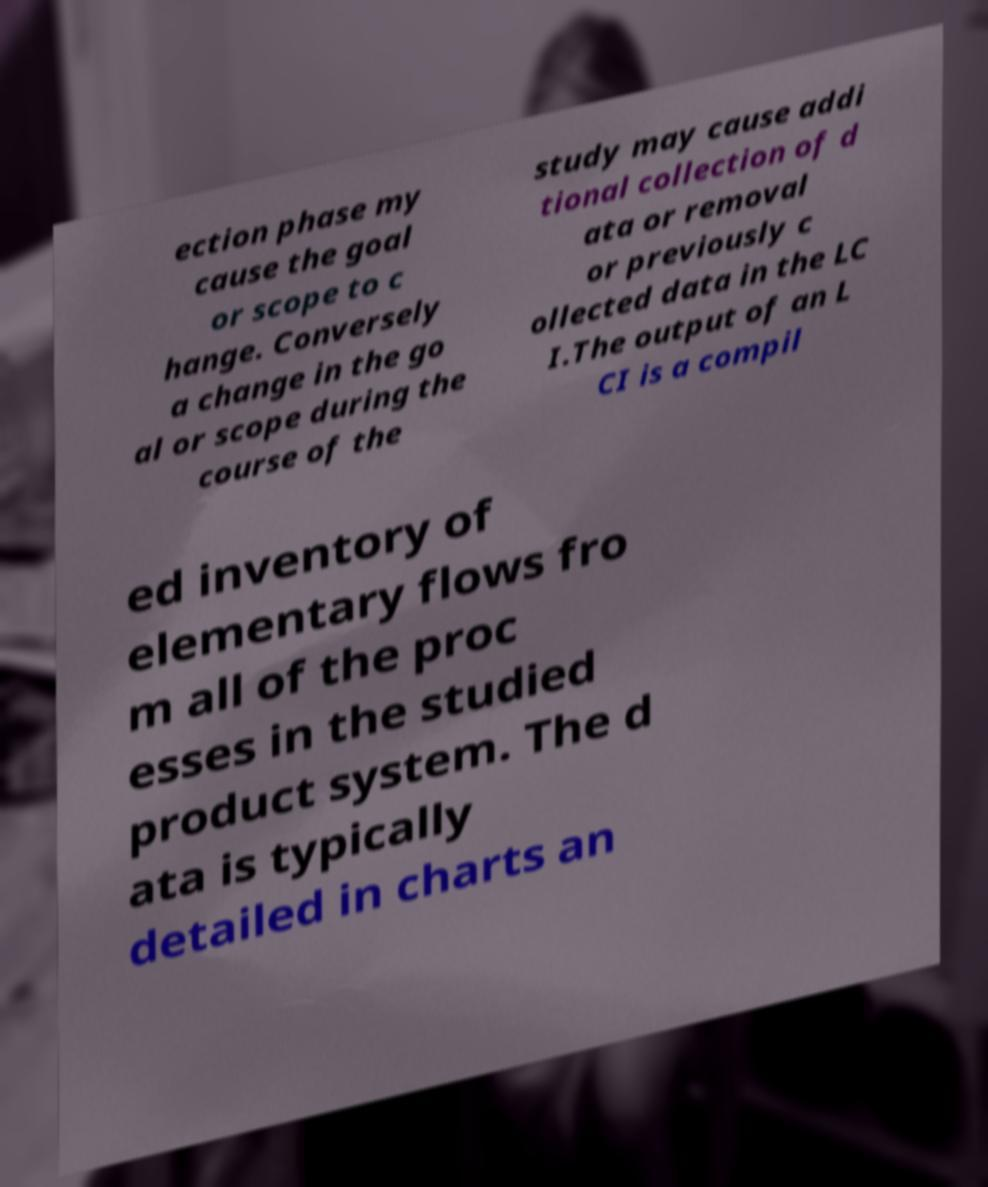What messages or text are displayed in this image? I need them in a readable, typed format. ection phase my cause the goal or scope to c hange. Conversely a change in the go al or scope during the course of the study may cause addi tional collection of d ata or removal or previously c ollected data in the LC I.The output of an L CI is a compil ed inventory of elementary flows fro m all of the proc esses in the studied product system. The d ata is typically detailed in charts an 